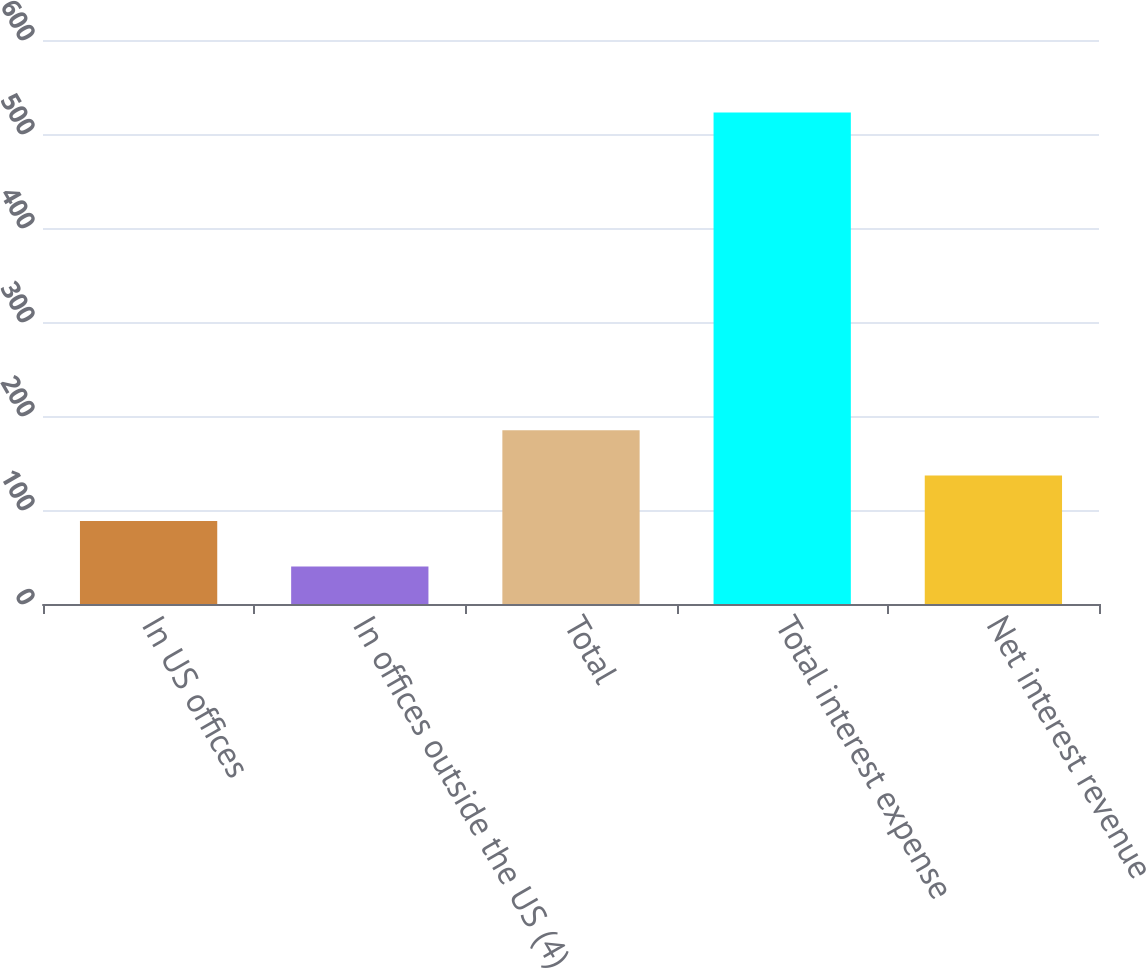<chart> <loc_0><loc_0><loc_500><loc_500><bar_chart><fcel>In US offices<fcel>In offices outside the US (4)<fcel>Total<fcel>Total interest expense<fcel>Net interest revenue<nl><fcel>88.3<fcel>40<fcel>184.9<fcel>523<fcel>136.6<nl></chart> 